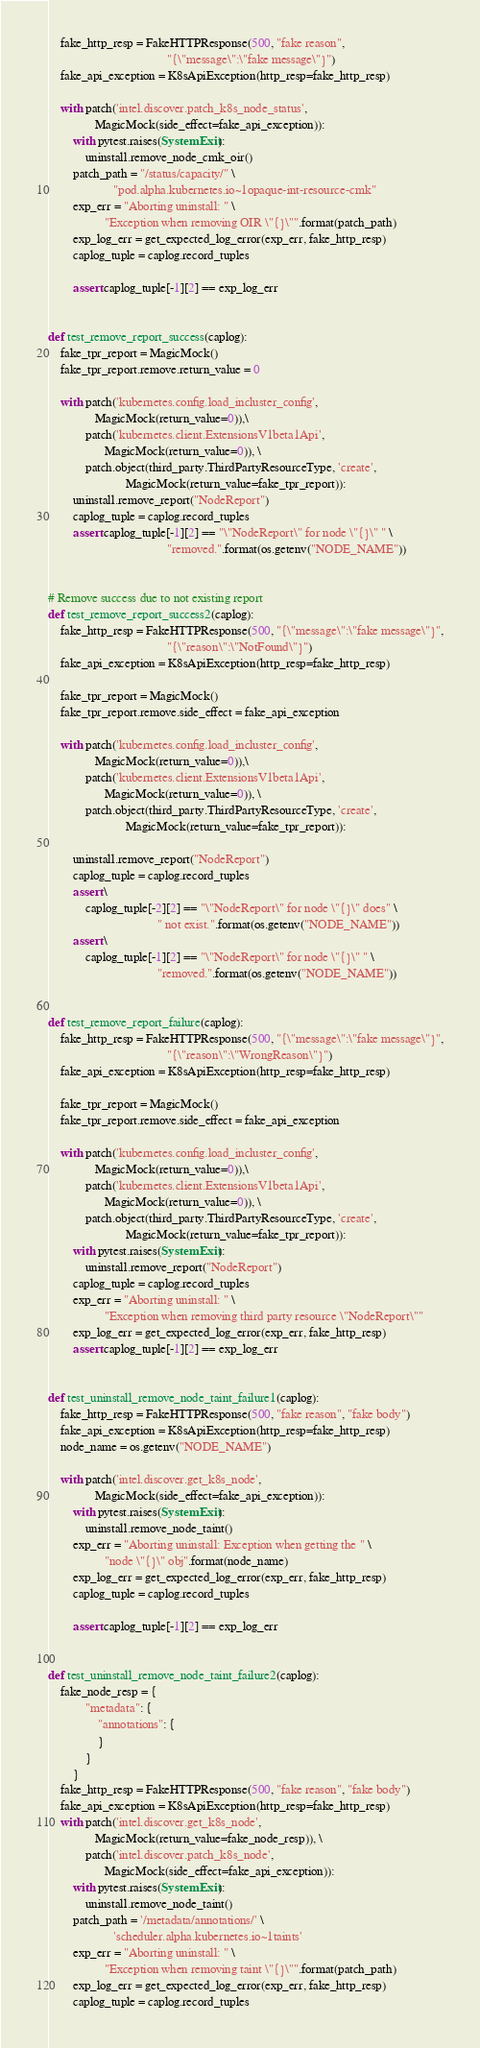Convert code to text. <code><loc_0><loc_0><loc_500><loc_500><_Python_>    fake_http_resp = FakeHTTPResponse(500, "fake reason",
                                      "{\"message\":\"fake message\"}")
    fake_api_exception = K8sApiException(http_resp=fake_http_resp)

    with patch('intel.discover.patch_k8s_node_status',
               MagicMock(side_effect=fake_api_exception)):
        with pytest.raises(SystemExit):
            uninstall.remove_node_cmk_oir()
        patch_path = "/status/capacity/" \
                     "pod.alpha.kubernetes.io~1opaque-int-resource-cmk"
        exp_err = "Aborting uninstall: " \
                  "Exception when removing OIR \"{}\"".format(patch_path)
        exp_log_err = get_expected_log_error(exp_err, fake_http_resp)
        caplog_tuple = caplog.record_tuples

        assert caplog_tuple[-1][2] == exp_log_err


def test_remove_report_success(caplog):
    fake_tpr_report = MagicMock()
    fake_tpr_report.remove.return_value = 0

    with patch('kubernetes.config.load_incluster_config',
               MagicMock(return_value=0)),\
            patch('kubernetes.client.ExtensionsV1beta1Api',
                  MagicMock(return_value=0)), \
            patch.object(third_party.ThirdPartyResourceType, 'create',
                         MagicMock(return_value=fake_tpr_report)):
        uninstall.remove_report("NodeReport")
        caplog_tuple = caplog.record_tuples
        assert caplog_tuple[-1][2] == "\"NodeReport\" for node \"{}\" " \
                                      "removed.".format(os.getenv("NODE_NAME"))


# Remove success due to not existing report
def test_remove_report_success2(caplog):
    fake_http_resp = FakeHTTPResponse(500, "{\"message\":\"fake message\"}",
                                      "{\"reason\":\"NotFound\"}")
    fake_api_exception = K8sApiException(http_resp=fake_http_resp)

    fake_tpr_report = MagicMock()
    fake_tpr_report.remove.side_effect = fake_api_exception

    with patch('kubernetes.config.load_incluster_config',
               MagicMock(return_value=0)),\
            patch('kubernetes.client.ExtensionsV1beta1Api',
                  MagicMock(return_value=0)), \
            patch.object(third_party.ThirdPartyResourceType, 'create',
                         MagicMock(return_value=fake_tpr_report)):

        uninstall.remove_report("NodeReport")
        caplog_tuple = caplog.record_tuples
        assert \
            caplog_tuple[-2][2] == "\"NodeReport\" for node \"{}\" does" \
                                   " not exist.".format(os.getenv("NODE_NAME"))
        assert \
            caplog_tuple[-1][2] == "\"NodeReport\" for node \"{}\" " \
                                   "removed.".format(os.getenv("NODE_NAME"))


def test_remove_report_failure(caplog):
    fake_http_resp = FakeHTTPResponse(500, "{\"message\":\"fake message\"}",
                                      "{\"reason\":\"WrongReason\"}")
    fake_api_exception = K8sApiException(http_resp=fake_http_resp)

    fake_tpr_report = MagicMock()
    fake_tpr_report.remove.side_effect = fake_api_exception

    with patch('kubernetes.config.load_incluster_config',
               MagicMock(return_value=0)),\
            patch('kubernetes.client.ExtensionsV1beta1Api',
                  MagicMock(return_value=0)), \
            patch.object(third_party.ThirdPartyResourceType, 'create',
                         MagicMock(return_value=fake_tpr_report)):
        with pytest.raises(SystemExit):
            uninstall.remove_report("NodeReport")
        caplog_tuple = caplog.record_tuples
        exp_err = "Aborting uninstall: " \
                  "Exception when removing third party resource \"NodeReport\""
        exp_log_err = get_expected_log_error(exp_err, fake_http_resp)
        assert caplog_tuple[-1][2] == exp_log_err


def test_uninstall_remove_node_taint_failure1(caplog):
    fake_http_resp = FakeHTTPResponse(500, "fake reason", "fake body")
    fake_api_exception = K8sApiException(http_resp=fake_http_resp)
    node_name = os.getenv("NODE_NAME")

    with patch('intel.discover.get_k8s_node',
               MagicMock(side_effect=fake_api_exception)):
        with pytest.raises(SystemExit):
            uninstall.remove_node_taint()
        exp_err = "Aborting uninstall: Exception when getting the " \
                  "node \"{}\" obj".format(node_name)
        exp_log_err = get_expected_log_error(exp_err, fake_http_resp)
        caplog_tuple = caplog.record_tuples

        assert caplog_tuple[-1][2] == exp_log_err


def test_uninstall_remove_node_taint_failure2(caplog):
    fake_node_resp = {
            "metadata": {
                "annotations": {
                }
            }
        }
    fake_http_resp = FakeHTTPResponse(500, "fake reason", "fake body")
    fake_api_exception = K8sApiException(http_resp=fake_http_resp)
    with patch('intel.discover.get_k8s_node',
               MagicMock(return_value=fake_node_resp)), \
            patch('intel.discover.patch_k8s_node',
                  MagicMock(side_effect=fake_api_exception)):
        with pytest.raises(SystemExit):
            uninstall.remove_node_taint()
        patch_path = '/metadata/annotations/' \
                     'scheduler.alpha.kubernetes.io~1taints'
        exp_err = "Aborting uninstall: " \
                  "Exception when removing taint \"{}\"".format(patch_path)
        exp_log_err = get_expected_log_error(exp_err, fake_http_resp)
        caplog_tuple = caplog.record_tuples
</code> 